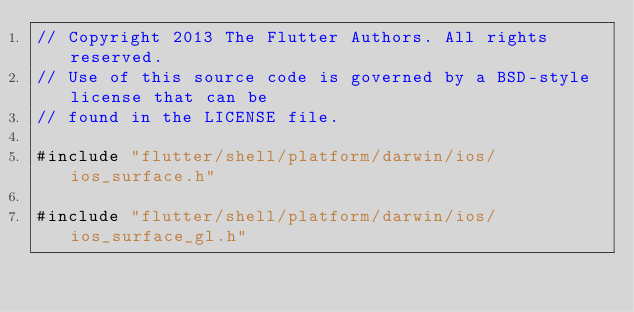<code> <loc_0><loc_0><loc_500><loc_500><_ObjectiveC_>// Copyright 2013 The Flutter Authors. All rights reserved.
// Use of this source code is governed by a BSD-style license that can be
// found in the LICENSE file.

#include "flutter/shell/platform/darwin/ios/ios_surface.h"

#include "flutter/shell/platform/darwin/ios/ios_surface_gl.h"</code> 